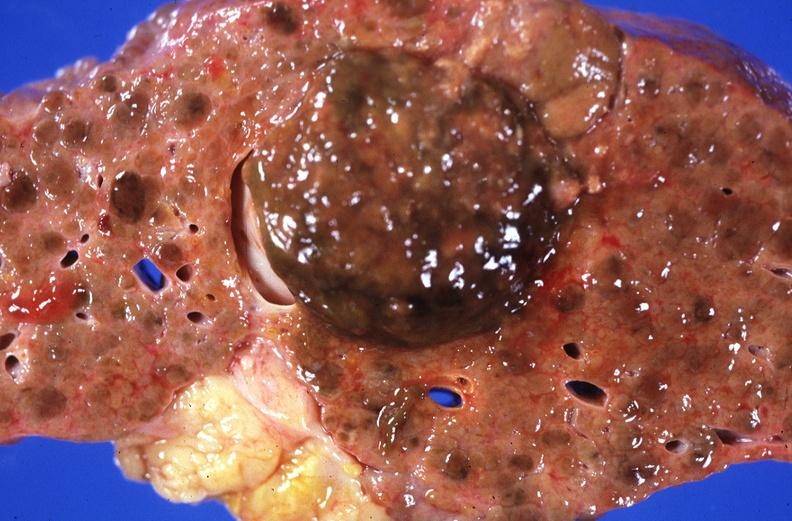what is present?
Answer the question using a single word or phrase. Liver 